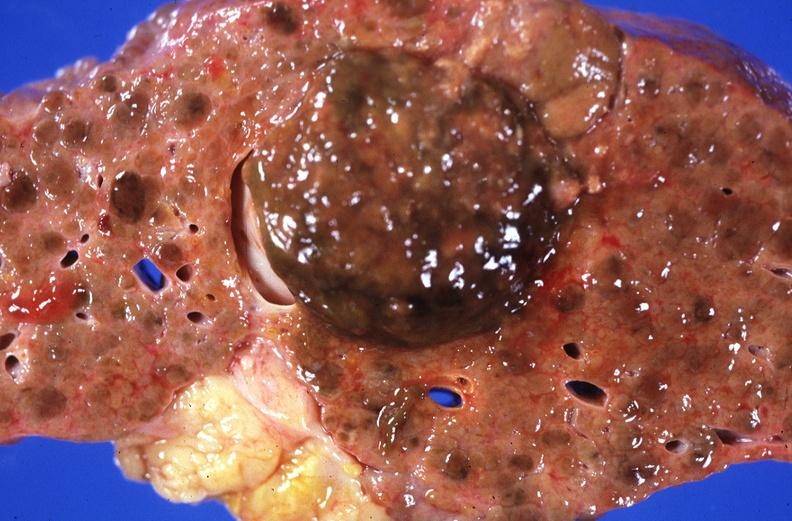what is present?
Answer the question using a single word or phrase. Liver 